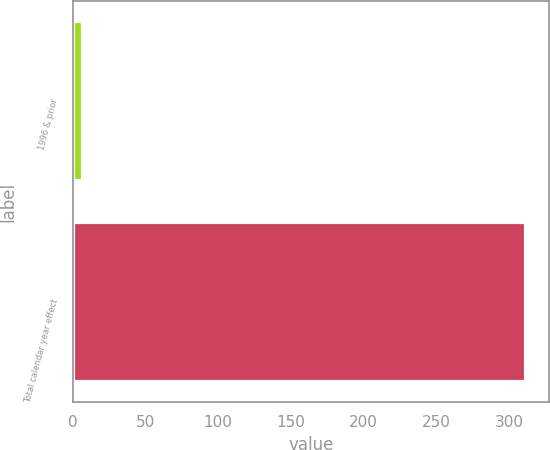<chart> <loc_0><loc_0><loc_500><loc_500><bar_chart><fcel>1996 & prior<fcel>Total calendar year effect<nl><fcel>7.2<fcel>312<nl></chart> 